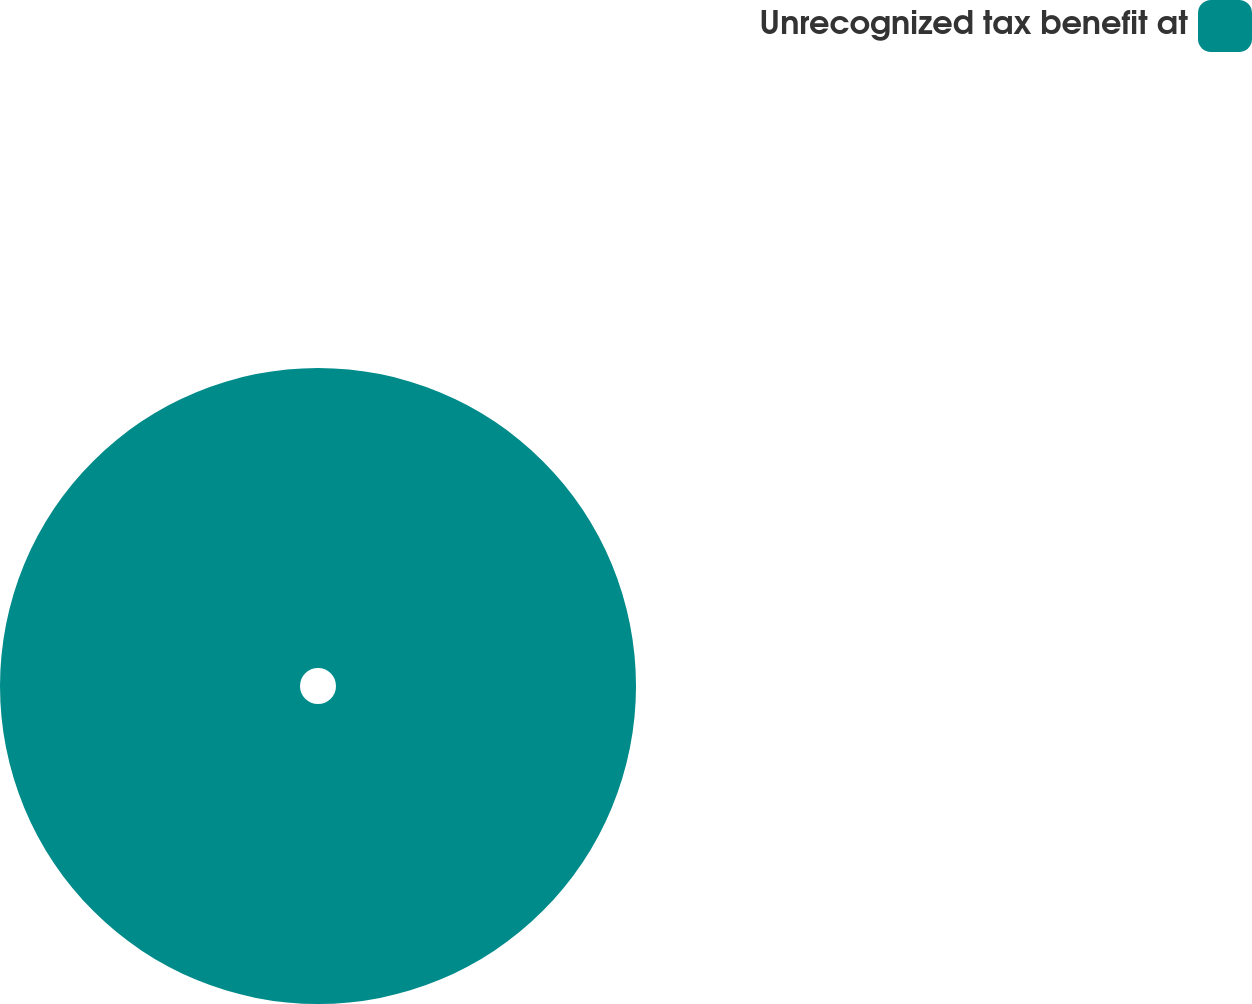Convert chart. <chart><loc_0><loc_0><loc_500><loc_500><pie_chart><fcel>Unrecognized tax benefit at<nl><fcel>100.0%<nl></chart> 